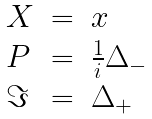Convert formula to latex. <formula><loc_0><loc_0><loc_500><loc_500>\begin{array} { l l l } X & = & x \\ P & = & \frac { 1 } { i } \Delta _ { - } \\ \Im & = & \Delta _ { + } \end{array}</formula> 